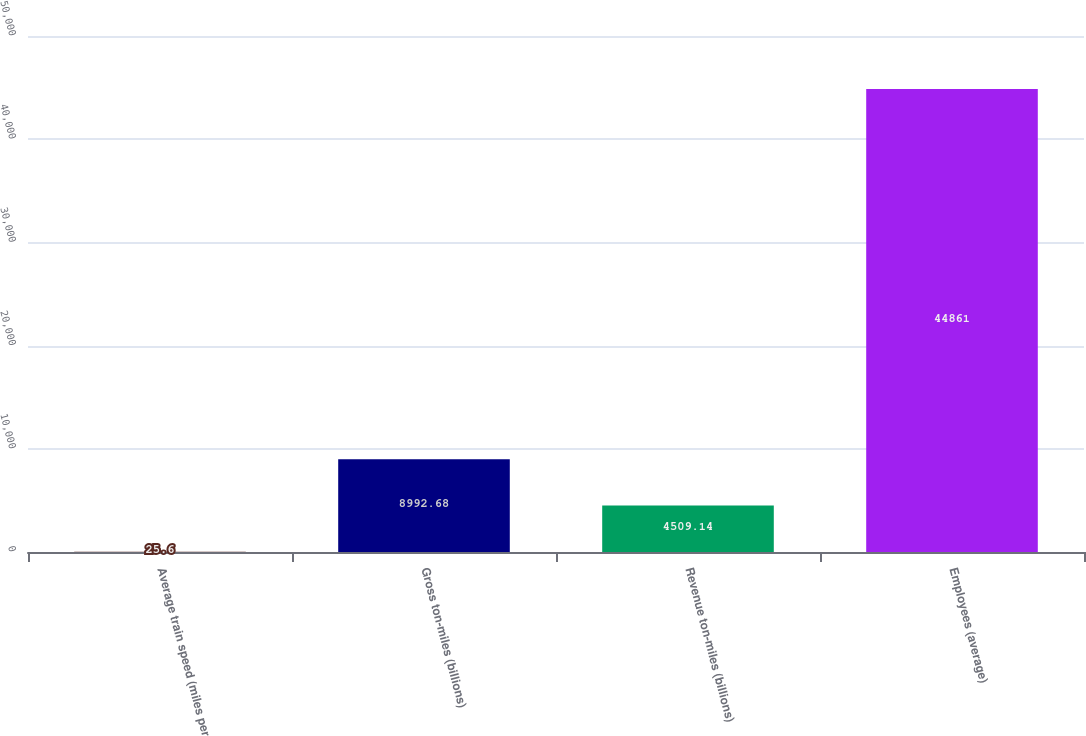Convert chart to OTSL. <chart><loc_0><loc_0><loc_500><loc_500><bar_chart><fcel>Average train speed (miles per<fcel>Gross ton-miles (billions)<fcel>Revenue ton-miles (billions)<fcel>Employees (average)<nl><fcel>25.6<fcel>8992.68<fcel>4509.14<fcel>44861<nl></chart> 